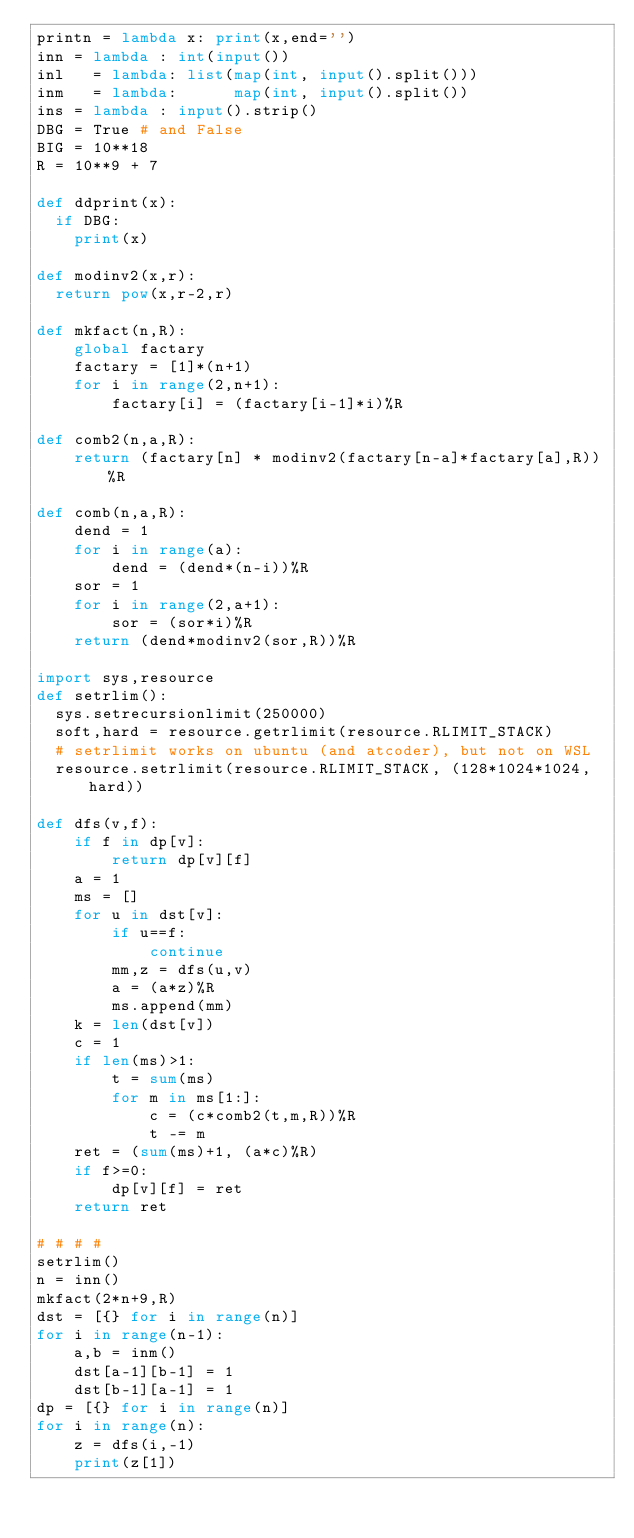Convert code to text. <code><loc_0><loc_0><loc_500><loc_500><_Python_>printn = lambda x: print(x,end='')
inn = lambda : int(input())
inl   = lambda: list(map(int, input().split()))
inm   = lambda:      map(int, input().split())
ins = lambda : input().strip()
DBG = True # and False
BIG = 10**18
R = 10**9 + 7

def ddprint(x):
  if DBG:
    print(x)

def modinv2(x,r):
  return pow(x,r-2,r)

def mkfact(n,R):
    global factary
    factary = [1]*(n+1)
    for i in range(2,n+1):
        factary[i] = (factary[i-1]*i)%R

def comb2(n,a,R):
    return (factary[n] * modinv2(factary[n-a]*factary[a],R))%R

def comb(n,a,R):
    dend = 1
    for i in range(a):
        dend = (dend*(n-i))%R
    sor = 1
    for i in range(2,a+1):
        sor = (sor*i)%R
    return (dend*modinv2(sor,R))%R

import sys,resource
def setrlim():
  sys.setrecursionlimit(250000)
  soft,hard = resource.getrlimit(resource.RLIMIT_STACK)
  # setrlimit works on ubuntu (and atcoder), but not on WSL
  resource.setrlimit(resource.RLIMIT_STACK, (128*1024*1024,hard))

def dfs(v,f):
    if f in dp[v]:
        return dp[v][f]
    a = 1
    ms = []
    for u in dst[v]:
        if u==f:
            continue
        mm,z = dfs(u,v)
        a = (a*z)%R
        ms.append(mm)
    k = len(dst[v])
    c = 1
    if len(ms)>1:
        t = sum(ms)
        for m in ms[1:]:
            c = (c*comb2(t,m,R))%R
            t -= m
    ret = (sum(ms)+1, (a*c)%R)
    if f>=0:
        dp[v][f] = ret
    return ret

# # # #
setrlim()
n = inn()
mkfact(2*n+9,R)
dst = [{} for i in range(n)]
for i in range(n-1):
    a,b = inm()
    dst[a-1][b-1] = 1
    dst[b-1][a-1] = 1
dp = [{} for i in range(n)]
for i in range(n):
    z = dfs(i,-1)
    print(z[1])
</code> 